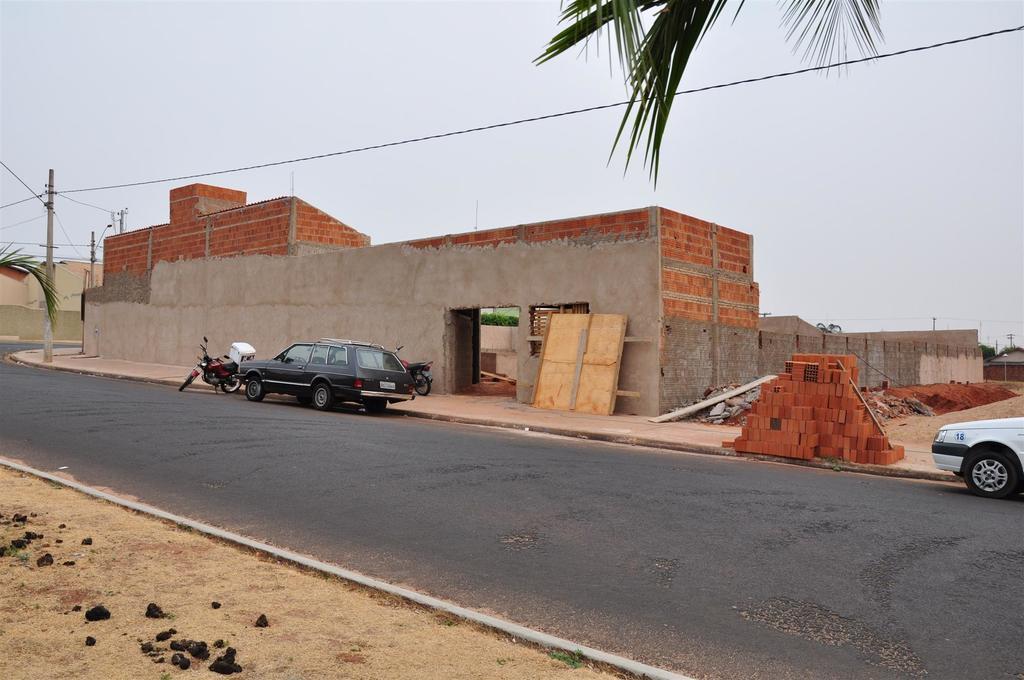Can you describe this image briefly? In this image I can see few vehicles on the road. Background I can see few bricks, building in gray color, electric pole, trees in green color and sky in gray color. 